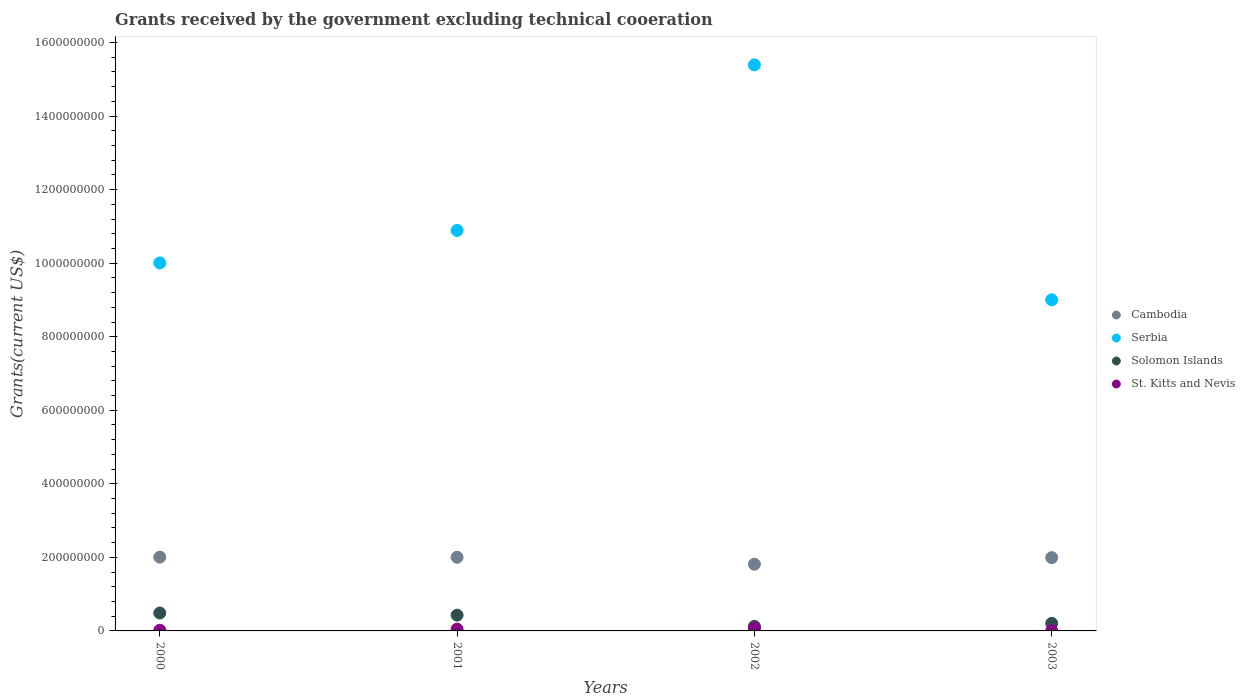Is the number of dotlines equal to the number of legend labels?
Your answer should be compact. Yes. What is the total grants received by the government in Cambodia in 2002?
Keep it short and to the point. 1.81e+08. Across all years, what is the maximum total grants received by the government in Serbia?
Your answer should be very brief. 1.54e+09. Across all years, what is the minimum total grants received by the government in Serbia?
Your answer should be very brief. 9.00e+08. In which year was the total grants received by the government in Solomon Islands minimum?
Offer a terse response. 2002. What is the total total grants received by the government in Cambodia in the graph?
Your response must be concise. 7.82e+08. What is the difference between the total grants received by the government in St. Kitts and Nevis in 2002 and that in 2003?
Your answer should be compact. 7.20e+06. What is the difference between the total grants received by the government in Cambodia in 2000 and the total grants received by the government in St. Kitts and Nevis in 2001?
Your answer should be compact. 1.96e+08. What is the average total grants received by the government in Solomon Islands per year?
Make the answer very short. 3.11e+07. In the year 2003, what is the difference between the total grants received by the government in St. Kitts and Nevis and total grants received by the government in Cambodia?
Your response must be concise. -1.99e+08. In how many years, is the total grants received by the government in Solomon Islands greater than 1000000000 US$?
Make the answer very short. 0. What is the ratio of the total grants received by the government in Serbia in 2000 to that in 2003?
Your answer should be compact. 1.11. Is the total grants received by the government in Solomon Islands in 2002 less than that in 2003?
Give a very brief answer. Yes. Is the difference between the total grants received by the government in St. Kitts and Nevis in 2001 and 2003 greater than the difference between the total grants received by the government in Cambodia in 2001 and 2003?
Keep it short and to the point. Yes. What is the difference between the highest and the second highest total grants received by the government in Serbia?
Make the answer very short. 4.50e+08. What is the difference between the highest and the lowest total grants received by the government in Cambodia?
Offer a very short reply. 1.92e+07. Is the sum of the total grants received by the government in Serbia in 2000 and 2003 greater than the maximum total grants received by the government in St. Kitts and Nevis across all years?
Offer a very short reply. Yes. Is it the case that in every year, the sum of the total grants received by the government in Cambodia and total grants received by the government in Serbia  is greater than the sum of total grants received by the government in St. Kitts and Nevis and total grants received by the government in Solomon Islands?
Give a very brief answer. Yes. Is it the case that in every year, the sum of the total grants received by the government in Serbia and total grants received by the government in St. Kitts and Nevis  is greater than the total grants received by the government in Solomon Islands?
Your response must be concise. Yes. Does the total grants received by the government in St. Kitts and Nevis monotonically increase over the years?
Your response must be concise. No. Is the total grants received by the government in Solomon Islands strictly less than the total grants received by the government in Cambodia over the years?
Offer a terse response. Yes. How many dotlines are there?
Provide a short and direct response. 4. Does the graph contain any zero values?
Your response must be concise. No. What is the title of the graph?
Offer a terse response. Grants received by the government excluding technical cooeration. What is the label or title of the Y-axis?
Your response must be concise. Grants(current US$). What is the Grants(current US$) of Cambodia in 2000?
Your response must be concise. 2.01e+08. What is the Grants(current US$) of Serbia in 2000?
Provide a short and direct response. 1.00e+09. What is the Grants(current US$) in Solomon Islands in 2000?
Provide a short and direct response. 4.87e+07. What is the Grants(current US$) in St. Kitts and Nevis in 2000?
Your answer should be compact. 1.80e+06. What is the Grants(current US$) in Cambodia in 2001?
Offer a terse response. 2.00e+08. What is the Grants(current US$) of Serbia in 2001?
Your answer should be very brief. 1.09e+09. What is the Grants(current US$) of Solomon Islands in 2001?
Provide a succinct answer. 4.30e+07. What is the Grants(current US$) of St. Kitts and Nevis in 2001?
Provide a succinct answer. 4.81e+06. What is the Grants(current US$) in Cambodia in 2002?
Ensure brevity in your answer.  1.81e+08. What is the Grants(current US$) of Serbia in 2002?
Offer a very short reply. 1.54e+09. What is the Grants(current US$) in Solomon Islands in 2002?
Your response must be concise. 1.24e+07. What is the Grants(current US$) in St. Kitts and Nevis in 2002?
Give a very brief answer. 7.61e+06. What is the Grants(current US$) in Cambodia in 2003?
Ensure brevity in your answer.  1.99e+08. What is the Grants(current US$) in Serbia in 2003?
Offer a very short reply. 9.00e+08. What is the Grants(current US$) of Solomon Islands in 2003?
Offer a very short reply. 2.05e+07. What is the Grants(current US$) in St. Kitts and Nevis in 2003?
Offer a terse response. 4.10e+05. Across all years, what is the maximum Grants(current US$) in Cambodia?
Provide a succinct answer. 2.01e+08. Across all years, what is the maximum Grants(current US$) of Serbia?
Your answer should be compact. 1.54e+09. Across all years, what is the maximum Grants(current US$) in Solomon Islands?
Provide a short and direct response. 4.87e+07. Across all years, what is the maximum Grants(current US$) in St. Kitts and Nevis?
Offer a terse response. 7.61e+06. Across all years, what is the minimum Grants(current US$) of Cambodia?
Keep it short and to the point. 1.81e+08. Across all years, what is the minimum Grants(current US$) of Serbia?
Offer a terse response. 9.00e+08. Across all years, what is the minimum Grants(current US$) of Solomon Islands?
Provide a succinct answer. 1.24e+07. What is the total Grants(current US$) in Cambodia in the graph?
Your answer should be very brief. 7.82e+08. What is the total Grants(current US$) in Serbia in the graph?
Provide a short and direct response. 4.53e+09. What is the total Grants(current US$) in Solomon Islands in the graph?
Make the answer very short. 1.25e+08. What is the total Grants(current US$) in St. Kitts and Nevis in the graph?
Your answer should be compact. 1.46e+07. What is the difference between the Grants(current US$) of Cambodia in 2000 and that in 2001?
Offer a very short reply. 3.30e+05. What is the difference between the Grants(current US$) in Serbia in 2000 and that in 2001?
Provide a succinct answer. -8.84e+07. What is the difference between the Grants(current US$) in Solomon Islands in 2000 and that in 2001?
Provide a short and direct response. 5.75e+06. What is the difference between the Grants(current US$) in St. Kitts and Nevis in 2000 and that in 2001?
Your response must be concise. -3.01e+06. What is the difference between the Grants(current US$) of Cambodia in 2000 and that in 2002?
Ensure brevity in your answer.  1.92e+07. What is the difference between the Grants(current US$) of Serbia in 2000 and that in 2002?
Provide a short and direct response. -5.39e+08. What is the difference between the Grants(current US$) in Solomon Islands in 2000 and that in 2002?
Your response must be concise. 3.64e+07. What is the difference between the Grants(current US$) of St. Kitts and Nevis in 2000 and that in 2002?
Ensure brevity in your answer.  -5.81e+06. What is the difference between the Grants(current US$) of Cambodia in 2000 and that in 2003?
Ensure brevity in your answer.  1.29e+06. What is the difference between the Grants(current US$) in Serbia in 2000 and that in 2003?
Offer a very short reply. 1.00e+08. What is the difference between the Grants(current US$) in Solomon Islands in 2000 and that in 2003?
Provide a short and direct response. 2.82e+07. What is the difference between the Grants(current US$) in St. Kitts and Nevis in 2000 and that in 2003?
Make the answer very short. 1.39e+06. What is the difference between the Grants(current US$) of Cambodia in 2001 and that in 2002?
Your answer should be compact. 1.89e+07. What is the difference between the Grants(current US$) of Serbia in 2001 and that in 2002?
Ensure brevity in your answer.  -4.50e+08. What is the difference between the Grants(current US$) in Solomon Islands in 2001 and that in 2002?
Provide a succinct answer. 3.06e+07. What is the difference between the Grants(current US$) in St. Kitts and Nevis in 2001 and that in 2002?
Provide a short and direct response. -2.80e+06. What is the difference between the Grants(current US$) of Cambodia in 2001 and that in 2003?
Keep it short and to the point. 9.60e+05. What is the difference between the Grants(current US$) of Serbia in 2001 and that in 2003?
Offer a terse response. 1.89e+08. What is the difference between the Grants(current US$) in Solomon Islands in 2001 and that in 2003?
Give a very brief answer. 2.24e+07. What is the difference between the Grants(current US$) in St. Kitts and Nevis in 2001 and that in 2003?
Provide a short and direct response. 4.40e+06. What is the difference between the Grants(current US$) of Cambodia in 2002 and that in 2003?
Provide a succinct answer. -1.80e+07. What is the difference between the Grants(current US$) in Serbia in 2002 and that in 2003?
Your answer should be very brief. 6.39e+08. What is the difference between the Grants(current US$) in Solomon Islands in 2002 and that in 2003?
Keep it short and to the point. -8.19e+06. What is the difference between the Grants(current US$) in St. Kitts and Nevis in 2002 and that in 2003?
Your response must be concise. 7.20e+06. What is the difference between the Grants(current US$) of Cambodia in 2000 and the Grants(current US$) of Serbia in 2001?
Keep it short and to the point. -8.88e+08. What is the difference between the Grants(current US$) in Cambodia in 2000 and the Grants(current US$) in Solomon Islands in 2001?
Your answer should be compact. 1.58e+08. What is the difference between the Grants(current US$) in Cambodia in 2000 and the Grants(current US$) in St. Kitts and Nevis in 2001?
Offer a terse response. 1.96e+08. What is the difference between the Grants(current US$) in Serbia in 2000 and the Grants(current US$) in Solomon Islands in 2001?
Give a very brief answer. 9.58e+08. What is the difference between the Grants(current US$) in Serbia in 2000 and the Grants(current US$) in St. Kitts and Nevis in 2001?
Make the answer very short. 9.96e+08. What is the difference between the Grants(current US$) of Solomon Islands in 2000 and the Grants(current US$) of St. Kitts and Nevis in 2001?
Offer a very short reply. 4.39e+07. What is the difference between the Grants(current US$) of Cambodia in 2000 and the Grants(current US$) of Serbia in 2002?
Ensure brevity in your answer.  -1.34e+09. What is the difference between the Grants(current US$) in Cambodia in 2000 and the Grants(current US$) in Solomon Islands in 2002?
Ensure brevity in your answer.  1.88e+08. What is the difference between the Grants(current US$) of Cambodia in 2000 and the Grants(current US$) of St. Kitts and Nevis in 2002?
Ensure brevity in your answer.  1.93e+08. What is the difference between the Grants(current US$) of Serbia in 2000 and the Grants(current US$) of Solomon Islands in 2002?
Your response must be concise. 9.88e+08. What is the difference between the Grants(current US$) of Serbia in 2000 and the Grants(current US$) of St. Kitts and Nevis in 2002?
Provide a succinct answer. 9.93e+08. What is the difference between the Grants(current US$) of Solomon Islands in 2000 and the Grants(current US$) of St. Kitts and Nevis in 2002?
Provide a short and direct response. 4.11e+07. What is the difference between the Grants(current US$) in Cambodia in 2000 and the Grants(current US$) in Serbia in 2003?
Your response must be concise. -7.00e+08. What is the difference between the Grants(current US$) in Cambodia in 2000 and the Grants(current US$) in Solomon Islands in 2003?
Ensure brevity in your answer.  1.80e+08. What is the difference between the Grants(current US$) of Cambodia in 2000 and the Grants(current US$) of St. Kitts and Nevis in 2003?
Your answer should be compact. 2.00e+08. What is the difference between the Grants(current US$) in Serbia in 2000 and the Grants(current US$) in Solomon Islands in 2003?
Ensure brevity in your answer.  9.80e+08. What is the difference between the Grants(current US$) of Serbia in 2000 and the Grants(current US$) of St. Kitts and Nevis in 2003?
Make the answer very short. 1.00e+09. What is the difference between the Grants(current US$) in Solomon Islands in 2000 and the Grants(current US$) in St. Kitts and Nevis in 2003?
Offer a terse response. 4.83e+07. What is the difference between the Grants(current US$) of Cambodia in 2001 and the Grants(current US$) of Serbia in 2002?
Your answer should be compact. -1.34e+09. What is the difference between the Grants(current US$) in Cambodia in 2001 and the Grants(current US$) in Solomon Islands in 2002?
Offer a very short reply. 1.88e+08. What is the difference between the Grants(current US$) in Cambodia in 2001 and the Grants(current US$) in St. Kitts and Nevis in 2002?
Ensure brevity in your answer.  1.93e+08. What is the difference between the Grants(current US$) in Serbia in 2001 and the Grants(current US$) in Solomon Islands in 2002?
Offer a terse response. 1.08e+09. What is the difference between the Grants(current US$) in Serbia in 2001 and the Grants(current US$) in St. Kitts and Nevis in 2002?
Your answer should be compact. 1.08e+09. What is the difference between the Grants(current US$) in Solomon Islands in 2001 and the Grants(current US$) in St. Kitts and Nevis in 2002?
Provide a short and direct response. 3.53e+07. What is the difference between the Grants(current US$) in Cambodia in 2001 and the Grants(current US$) in Serbia in 2003?
Provide a short and direct response. -7.00e+08. What is the difference between the Grants(current US$) in Cambodia in 2001 and the Grants(current US$) in Solomon Islands in 2003?
Ensure brevity in your answer.  1.80e+08. What is the difference between the Grants(current US$) in Cambodia in 2001 and the Grants(current US$) in St. Kitts and Nevis in 2003?
Your answer should be compact. 2.00e+08. What is the difference between the Grants(current US$) of Serbia in 2001 and the Grants(current US$) of Solomon Islands in 2003?
Give a very brief answer. 1.07e+09. What is the difference between the Grants(current US$) in Serbia in 2001 and the Grants(current US$) in St. Kitts and Nevis in 2003?
Give a very brief answer. 1.09e+09. What is the difference between the Grants(current US$) of Solomon Islands in 2001 and the Grants(current US$) of St. Kitts and Nevis in 2003?
Your response must be concise. 4.25e+07. What is the difference between the Grants(current US$) in Cambodia in 2002 and the Grants(current US$) in Serbia in 2003?
Offer a very short reply. -7.19e+08. What is the difference between the Grants(current US$) in Cambodia in 2002 and the Grants(current US$) in Solomon Islands in 2003?
Offer a terse response. 1.61e+08. What is the difference between the Grants(current US$) in Cambodia in 2002 and the Grants(current US$) in St. Kitts and Nevis in 2003?
Provide a short and direct response. 1.81e+08. What is the difference between the Grants(current US$) of Serbia in 2002 and the Grants(current US$) of Solomon Islands in 2003?
Give a very brief answer. 1.52e+09. What is the difference between the Grants(current US$) of Serbia in 2002 and the Grants(current US$) of St. Kitts and Nevis in 2003?
Offer a terse response. 1.54e+09. What is the difference between the Grants(current US$) of Solomon Islands in 2002 and the Grants(current US$) of St. Kitts and Nevis in 2003?
Your answer should be very brief. 1.19e+07. What is the average Grants(current US$) of Cambodia per year?
Offer a very short reply. 1.95e+08. What is the average Grants(current US$) in Serbia per year?
Offer a very short reply. 1.13e+09. What is the average Grants(current US$) in Solomon Islands per year?
Make the answer very short. 3.11e+07. What is the average Grants(current US$) of St. Kitts and Nevis per year?
Your response must be concise. 3.66e+06. In the year 2000, what is the difference between the Grants(current US$) in Cambodia and Grants(current US$) in Serbia?
Keep it short and to the point. -8.00e+08. In the year 2000, what is the difference between the Grants(current US$) in Cambodia and Grants(current US$) in Solomon Islands?
Give a very brief answer. 1.52e+08. In the year 2000, what is the difference between the Grants(current US$) in Cambodia and Grants(current US$) in St. Kitts and Nevis?
Keep it short and to the point. 1.99e+08. In the year 2000, what is the difference between the Grants(current US$) of Serbia and Grants(current US$) of Solomon Islands?
Ensure brevity in your answer.  9.52e+08. In the year 2000, what is the difference between the Grants(current US$) in Serbia and Grants(current US$) in St. Kitts and Nevis?
Provide a short and direct response. 9.99e+08. In the year 2000, what is the difference between the Grants(current US$) of Solomon Islands and Grants(current US$) of St. Kitts and Nevis?
Keep it short and to the point. 4.69e+07. In the year 2001, what is the difference between the Grants(current US$) of Cambodia and Grants(current US$) of Serbia?
Provide a succinct answer. -8.89e+08. In the year 2001, what is the difference between the Grants(current US$) of Cambodia and Grants(current US$) of Solomon Islands?
Provide a succinct answer. 1.57e+08. In the year 2001, what is the difference between the Grants(current US$) of Cambodia and Grants(current US$) of St. Kitts and Nevis?
Your answer should be compact. 1.96e+08. In the year 2001, what is the difference between the Grants(current US$) in Serbia and Grants(current US$) in Solomon Islands?
Your response must be concise. 1.05e+09. In the year 2001, what is the difference between the Grants(current US$) of Serbia and Grants(current US$) of St. Kitts and Nevis?
Keep it short and to the point. 1.08e+09. In the year 2001, what is the difference between the Grants(current US$) of Solomon Islands and Grants(current US$) of St. Kitts and Nevis?
Your response must be concise. 3.81e+07. In the year 2002, what is the difference between the Grants(current US$) in Cambodia and Grants(current US$) in Serbia?
Your answer should be very brief. -1.36e+09. In the year 2002, what is the difference between the Grants(current US$) of Cambodia and Grants(current US$) of Solomon Islands?
Keep it short and to the point. 1.69e+08. In the year 2002, what is the difference between the Grants(current US$) of Cambodia and Grants(current US$) of St. Kitts and Nevis?
Ensure brevity in your answer.  1.74e+08. In the year 2002, what is the difference between the Grants(current US$) of Serbia and Grants(current US$) of Solomon Islands?
Your answer should be compact. 1.53e+09. In the year 2002, what is the difference between the Grants(current US$) of Serbia and Grants(current US$) of St. Kitts and Nevis?
Make the answer very short. 1.53e+09. In the year 2002, what is the difference between the Grants(current US$) in Solomon Islands and Grants(current US$) in St. Kitts and Nevis?
Ensure brevity in your answer.  4.74e+06. In the year 2003, what is the difference between the Grants(current US$) of Cambodia and Grants(current US$) of Serbia?
Offer a very short reply. -7.01e+08. In the year 2003, what is the difference between the Grants(current US$) in Cambodia and Grants(current US$) in Solomon Islands?
Your answer should be very brief. 1.79e+08. In the year 2003, what is the difference between the Grants(current US$) in Cambodia and Grants(current US$) in St. Kitts and Nevis?
Your answer should be very brief. 1.99e+08. In the year 2003, what is the difference between the Grants(current US$) in Serbia and Grants(current US$) in Solomon Islands?
Offer a very short reply. 8.80e+08. In the year 2003, what is the difference between the Grants(current US$) of Serbia and Grants(current US$) of St. Kitts and Nevis?
Offer a terse response. 9.00e+08. In the year 2003, what is the difference between the Grants(current US$) of Solomon Islands and Grants(current US$) of St. Kitts and Nevis?
Keep it short and to the point. 2.01e+07. What is the ratio of the Grants(current US$) of Serbia in 2000 to that in 2001?
Your answer should be very brief. 0.92. What is the ratio of the Grants(current US$) of Solomon Islands in 2000 to that in 2001?
Your answer should be very brief. 1.13. What is the ratio of the Grants(current US$) in St. Kitts and Nevis in 2000 to that in 2001?
Keep it short and to the point. 0.37. What is the ratio of the Grants(current US$) of Cambodia in 2000 to that in 2002?
Make the answer very short. 1.11. What is the ratio of the Grants(current US$) of Serbia in 2000 to that in 2002?
Give a very brief answer. 0.65. What is the ratio of the Grants(current US$) in Solomon Islands in 2000 to that in 2002?
Your response must be concise. 3.94. What is the ratio of the Grants(current US$) in St. Kitts and Nevis in 2000 to that in 2002?
Ensure brevity in your answer.  0.24. What is the ratio of the Grants(current US$) in Cambodia in 2000 to that in 2003?
Your answer should be compact. 1.01. What is the ratio of the Grants(current US$) in Serbia in 2000 to that in 2003?
Provide a succinct answer. 1.11. What is the ratio of the Grants(current US$) in Solomon Islands in 2000 to that in 2003?
Offer a terse response. 2.37. What is the ratio of the Grants(current US$) of St. Kitts and Nevis in 2000 to that in 2003?
Provide a short and direct response. 4.39. What is the ratio of the Grants(current US$) in Cambodia in 2001 to that in 2002?
Give a very brief answer. 1.1. What is the ratio of the Grants(current US$) of Serbia in 2001 to that in 2002?
Ensure brevity in your answer.  0.71. What is the ratio of the Grants(current US$) of Solomon Islands in 2001 to that in 2002?
Provide a succinct answer. 3.48. What is the ratio of the Grants(current US$) of St. Kitts and Nevis in 2001 to that in 2002?
Your answer should be compact. 0.63. What is the ratio of the Grants(current US$) of Serbia in 2001 to that in 2003?
Provide a short and direct response. 1.21. What is the ratio of the Grants(current US$) of Solomon Islands in 2001 to that in 2003?
Your response must be concise. 2.09. What is the ratio of the Grants(current US$) in St. Kitts and Nevis in 2001 to that in 2003?
Your answer should be compact. 11.73. What is the ratio of the Grants(current US$) in Cambodia in 2002 to that in 2003?
Provide a short and direct response. 0.91. What is the ratio of the Grants(current US$) in Serbia in 2002 to that in 2003?
Provide a short and direct response. 1.71. What is the ratio of the Grants(current US$) in Solomon Islands in 2002 to that in 2003?
Offer a terse response. 0.6. What is the ratio of the Grants(current US$) in St. Kitts and Nevis in 2002 to that in 2003?
Provide a succinct answer. 18.56. What is the difference between the highest and the second highest Grants(current US$) of Cambodia?
Your answer should be very brief. 3.30e+05. What is the difference between the highest and the second highest Grants(current US$) in Serbia?
Offer a terse response. 4.50e+08. What is the difference between the highest and the second highest Grants(current US$) of Solomon Islands?
Make the answer very short. 5.75e+06. What is the difference between the highest and the second highest Grants(current US$) of St. Kitts and Nevis?
Ensure brevity in your answer.  2.80e+06. What is the difference between the highest and the lowest Grants(current US$) of Cambodia?
Make the answer very short. 1.92e+07. What is the difference between the highest and the lowest Grants(current US$) in Serbia?
Give a very brief answer. 6.39e+08. What is the difference between the highest and the lowest Grants(current US$) of Solomon Islands?
Provide a short and direct response. 3.64e+07. What is the difference between the highest and the lowest Grants(current US$) of St. Kitts and Nevis?
Offer a very short reply. 7.20e+06. 